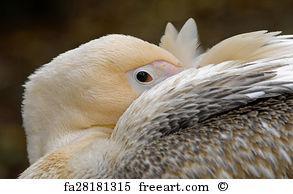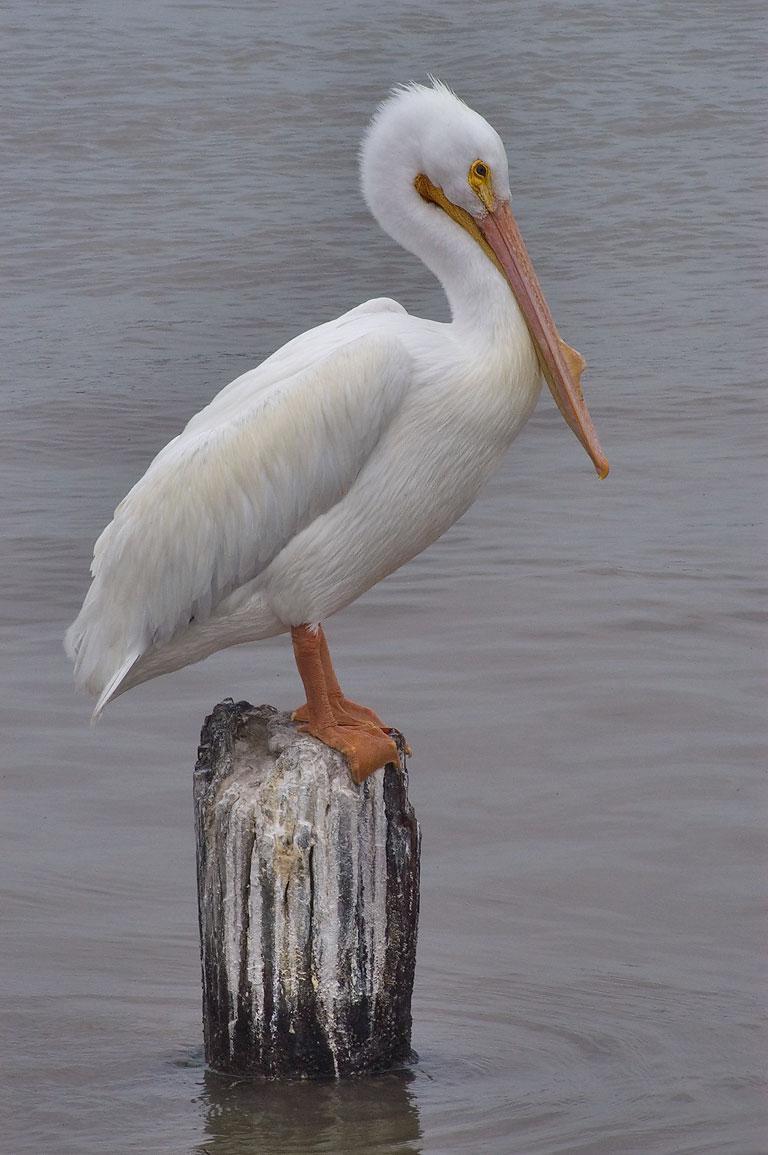The first image is the image on the left, the second image is the image on the right. Analyze the images presented: Is the assertion "There is a bird facing towards the left in the left image." valid? Answer yes or no. No. The first image is the image on the left, the second image is the image on the right. For the images displayed, is the sentence "Each image contains exactly one pelican, and all pelicans have a flattened pose with bill resting on breast." factually correct? Answer yes or no. No. 